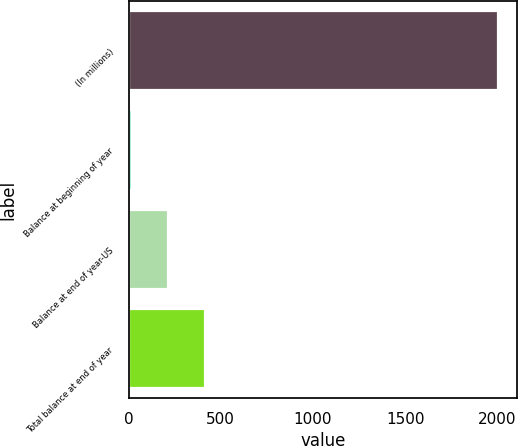Convert chart. <chart><loc_0><loc_0><loc_500><loc_500><bar_chart><fcel>(In millions)<fcel>Balance at beginning of year<fcel>Balance at end of year-US<fcel>Total balance at end of year<nl><fcel>2006<fcel>17<fcel>215.9<fcel>414.8<nl></chart> 